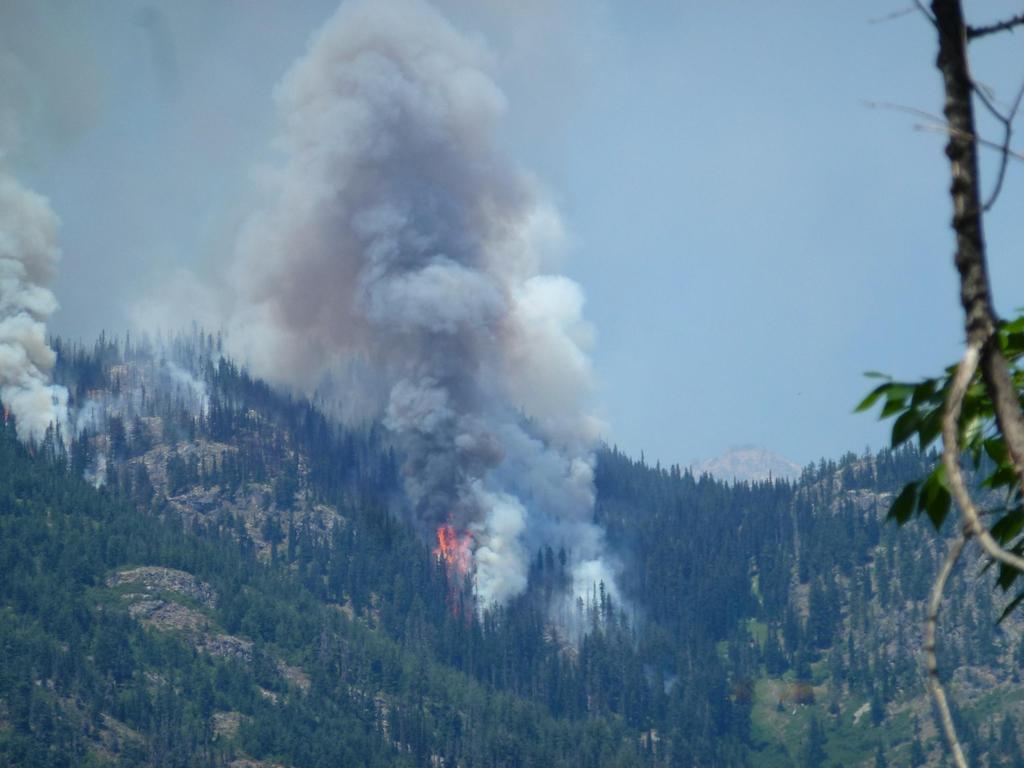In one or two sentences, can you explain what this image depicts? Here we can see trees, fire, and smoke. In the background there is sky. 